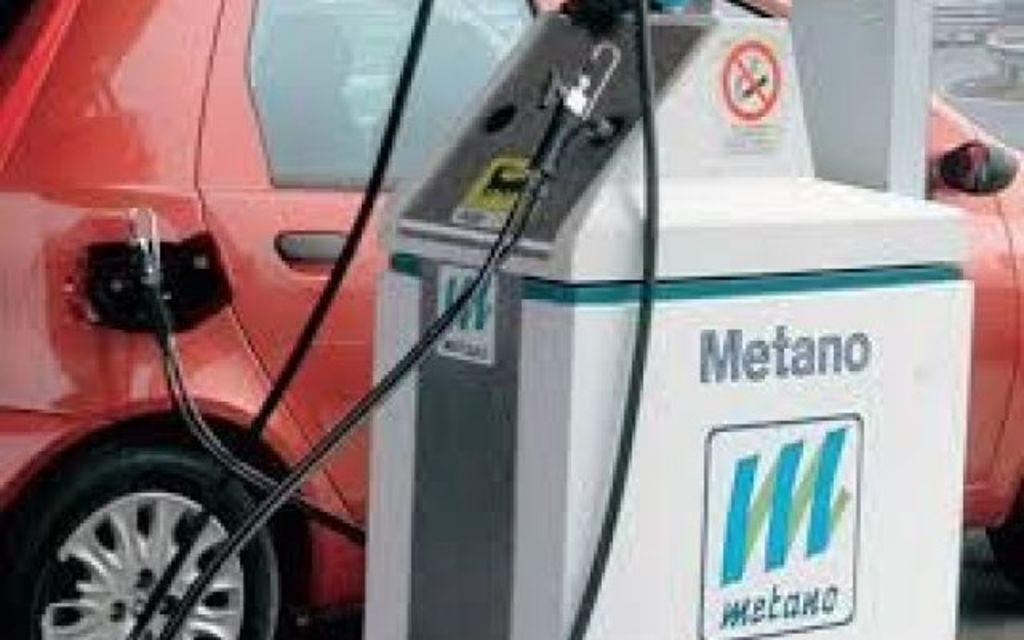What is the main object in the image? There is a petrol pumping machine in the image. What else can be seen in the image? There is a red color car in the image. Why is the plate spinning in the image? There is no plate present in the image, let alone a spinning one. 